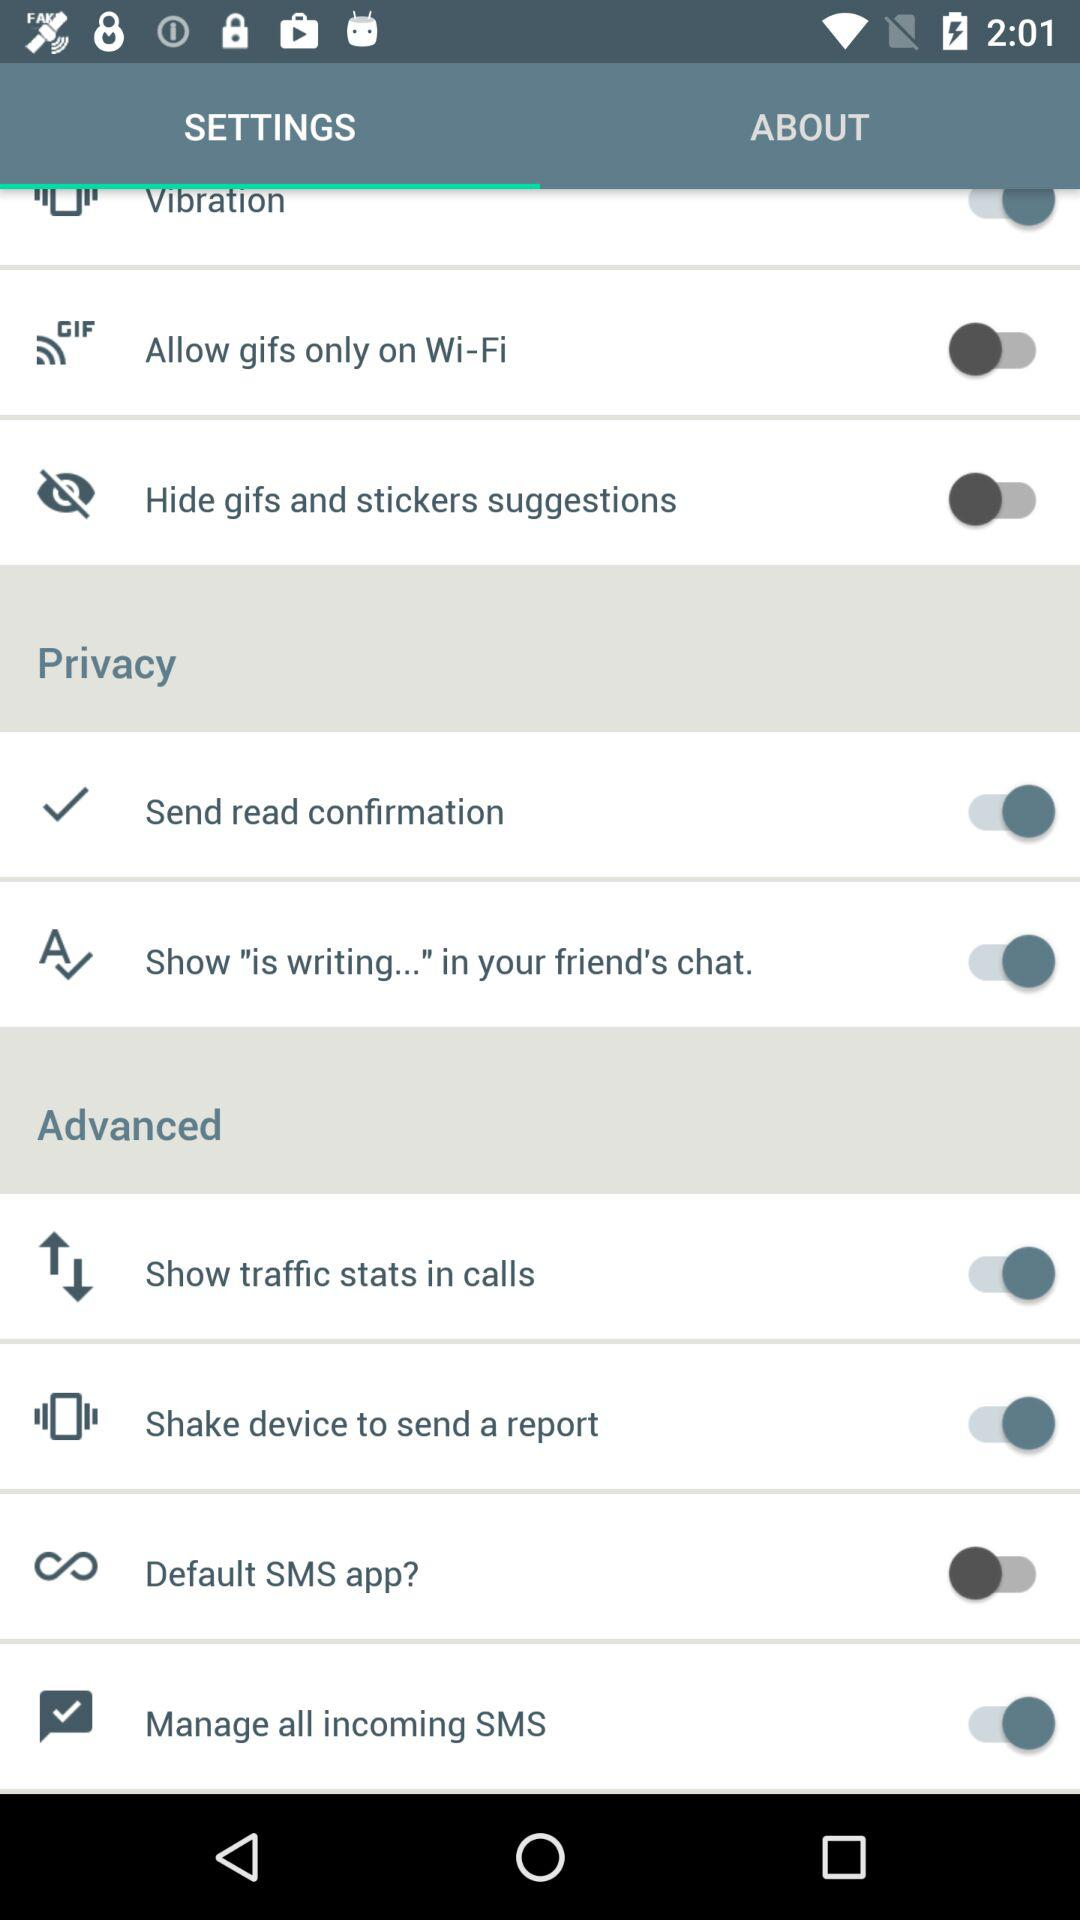What's the status of "Shake device to send a report"? The status is "on". 